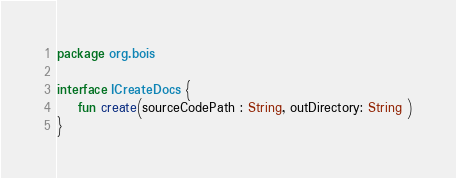<code> <loc_0><loc_0><loc_500><loc_500><_Kotlin_>package org.bois

interface ICreateDocs {
    fun create(sourceCodePath : String, outDirectory: String )
}</code> 